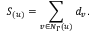<formula> <loc_0><loc_0><loc_500><loc_500>S _ { ( u ) } = \sum _ { v \in N _ { \Gamma } ( u ) } d _ { v } .</formula> 